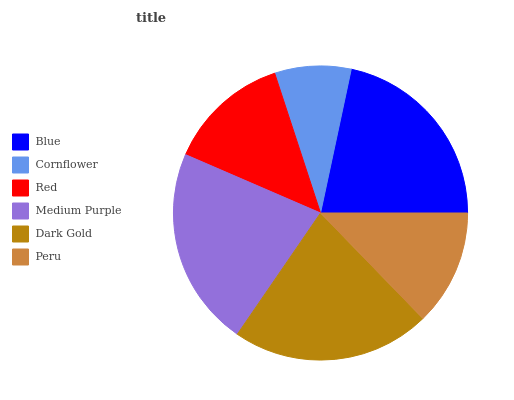Is Cornflower the minimum?
Answer yes or no. Yes. Is Medium Purple the maximum?
Answer yes or no. Yes. Is Red the minimum?
Answer yes or no. No. Is Red the maximum?
Answer yes or no. No. Is Red greater than Cornflower?
Answer yes or no. Yes. Is Cornflower less than Red?
Answer yes or no. Yes. Is Cornflower greater than Red?
Answer yes or no. No. Is Red less than Cornflower?
Answer yes or no. No. Is Blue the high median?
Answer yes or no. Yes. Is Red the low median?
Answer yes or no. Yes. Is Medium Purple the high median?
Answer yes or no. No. Is Medium Purple the low median?
Answer yes or no. No. 